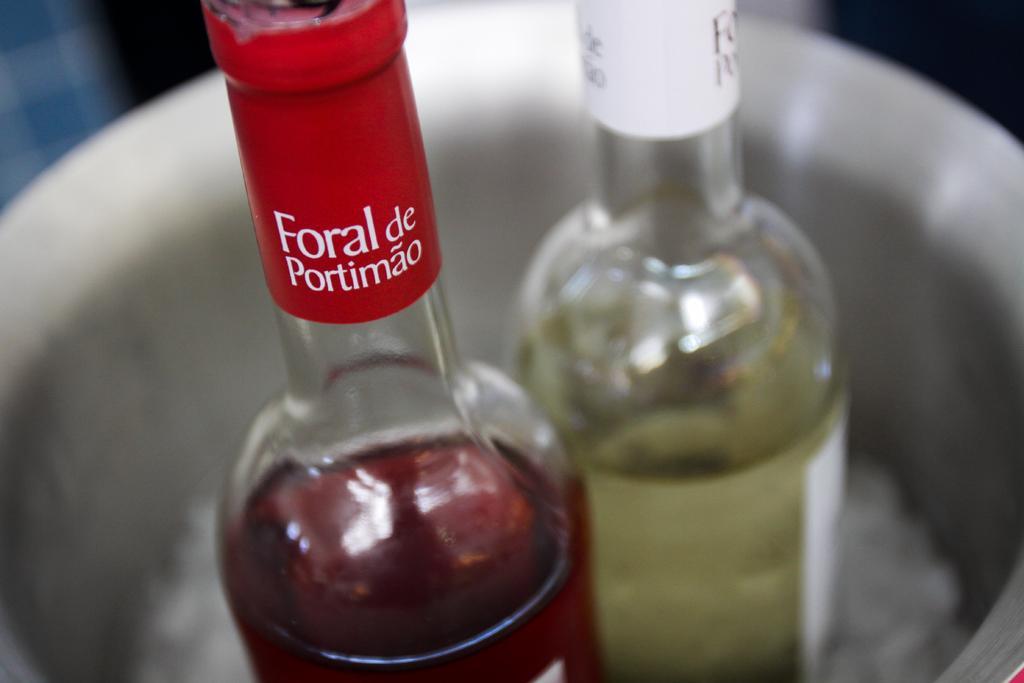Please provide a concise description of this image. 2 bottles in a container. 